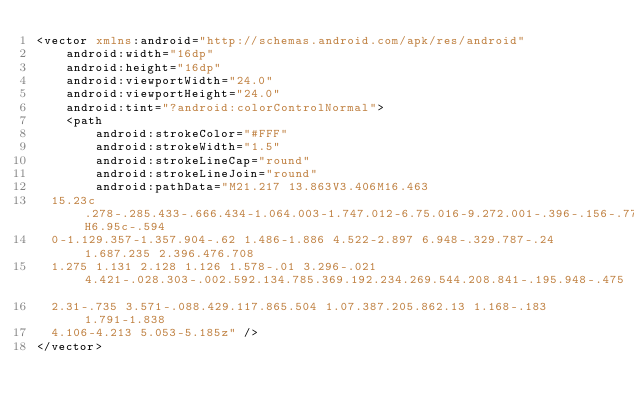Convert code to text. <code><loc_0><loc_0><loc_500><loc_500><_XML_><vector xmlns:android="http://schemas.android.com/apk/res/android"
    android:width="16dp"
    android:height="16dp"
    android:viewportWidth="24.0"
    android:viewportHeight="24.0"
    android:tint="?android:colorControlNormal">
    <path
        android:strokeColor="#FFF"
        android:strokeWidth="1.5"
        android:strokeLineCap="round"
        android:strokeLineJoin="round"
        android:pathData="M21.217 13.863V3.406M16.463
  15.23c.278-.285.433-.666.434-1.064.003-1.747.012-6.75.016-9.272.001-.396-.156-.775-.435-1.055-.28-.28-.659-.438-1.055-.438H6.95c-.594
  0-1.129.357-1.357.904-.62 1.486-1.886 4.522-2.897 6.948-.329.787-.24 1.687.235 2.396.476.708
  1.275 1.131 2.128 1.126 1.578-.01 3.296-.021 4.421-.028.303-.002.592.134.785.369.192.234.269.544.208.841-.195.948-.475
  2.31-.735 3.571-.088.429.117.865.504 1.07.387.205.862.13 1.168-.183 1.791-1.838
  4.106-4.213 5.053-5.185z" />
</vector></code> 